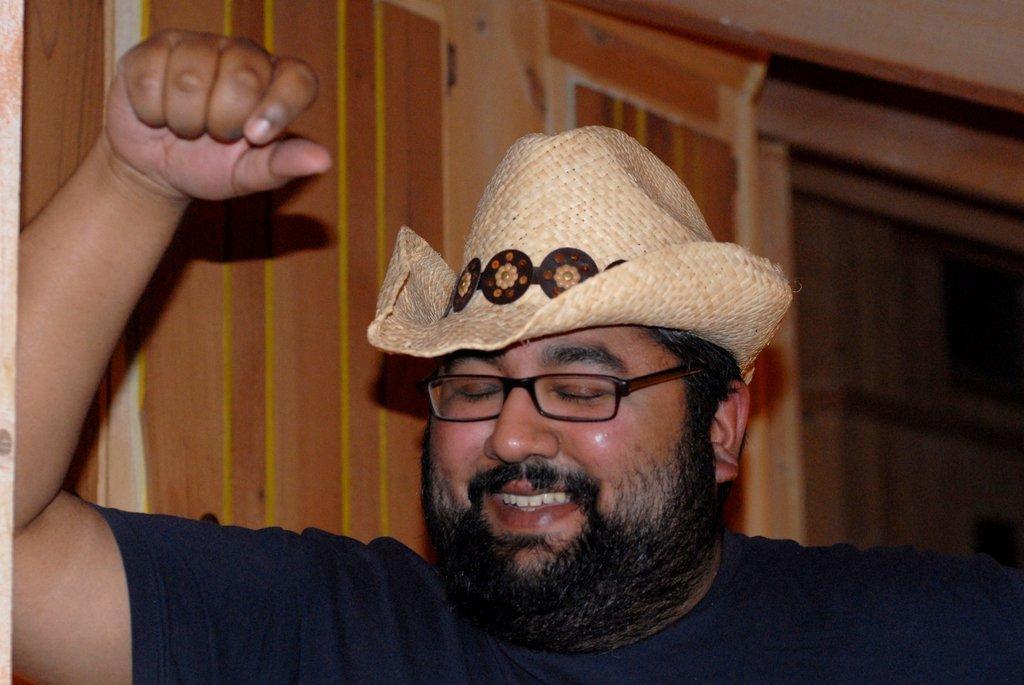Could you give a brief overview of what you see in this image? In this picture I can see there is a man standing here and he is wearing a cap, spectacles and in the backdrop there is a door and a wall. 